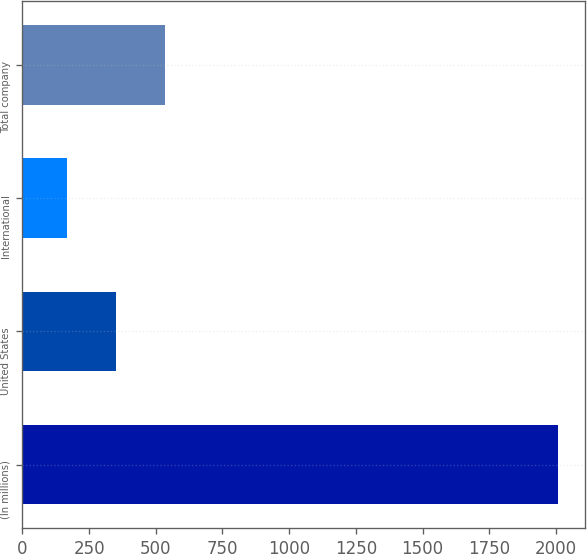Convert chart. <chart><loc_0><loc_0><loc_500><loc_500><bar_chart><fcel>(In millions)<fcel>United States<fcel>International<fcel>Total company<nl><fcel>2007<fcel>350.1<fcel>166<fcel>534.2<nl></chart> 